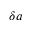Convert formula to latex. <formula><loc_0><loc_0><loc_500><loc_500>\delta a</formula> 